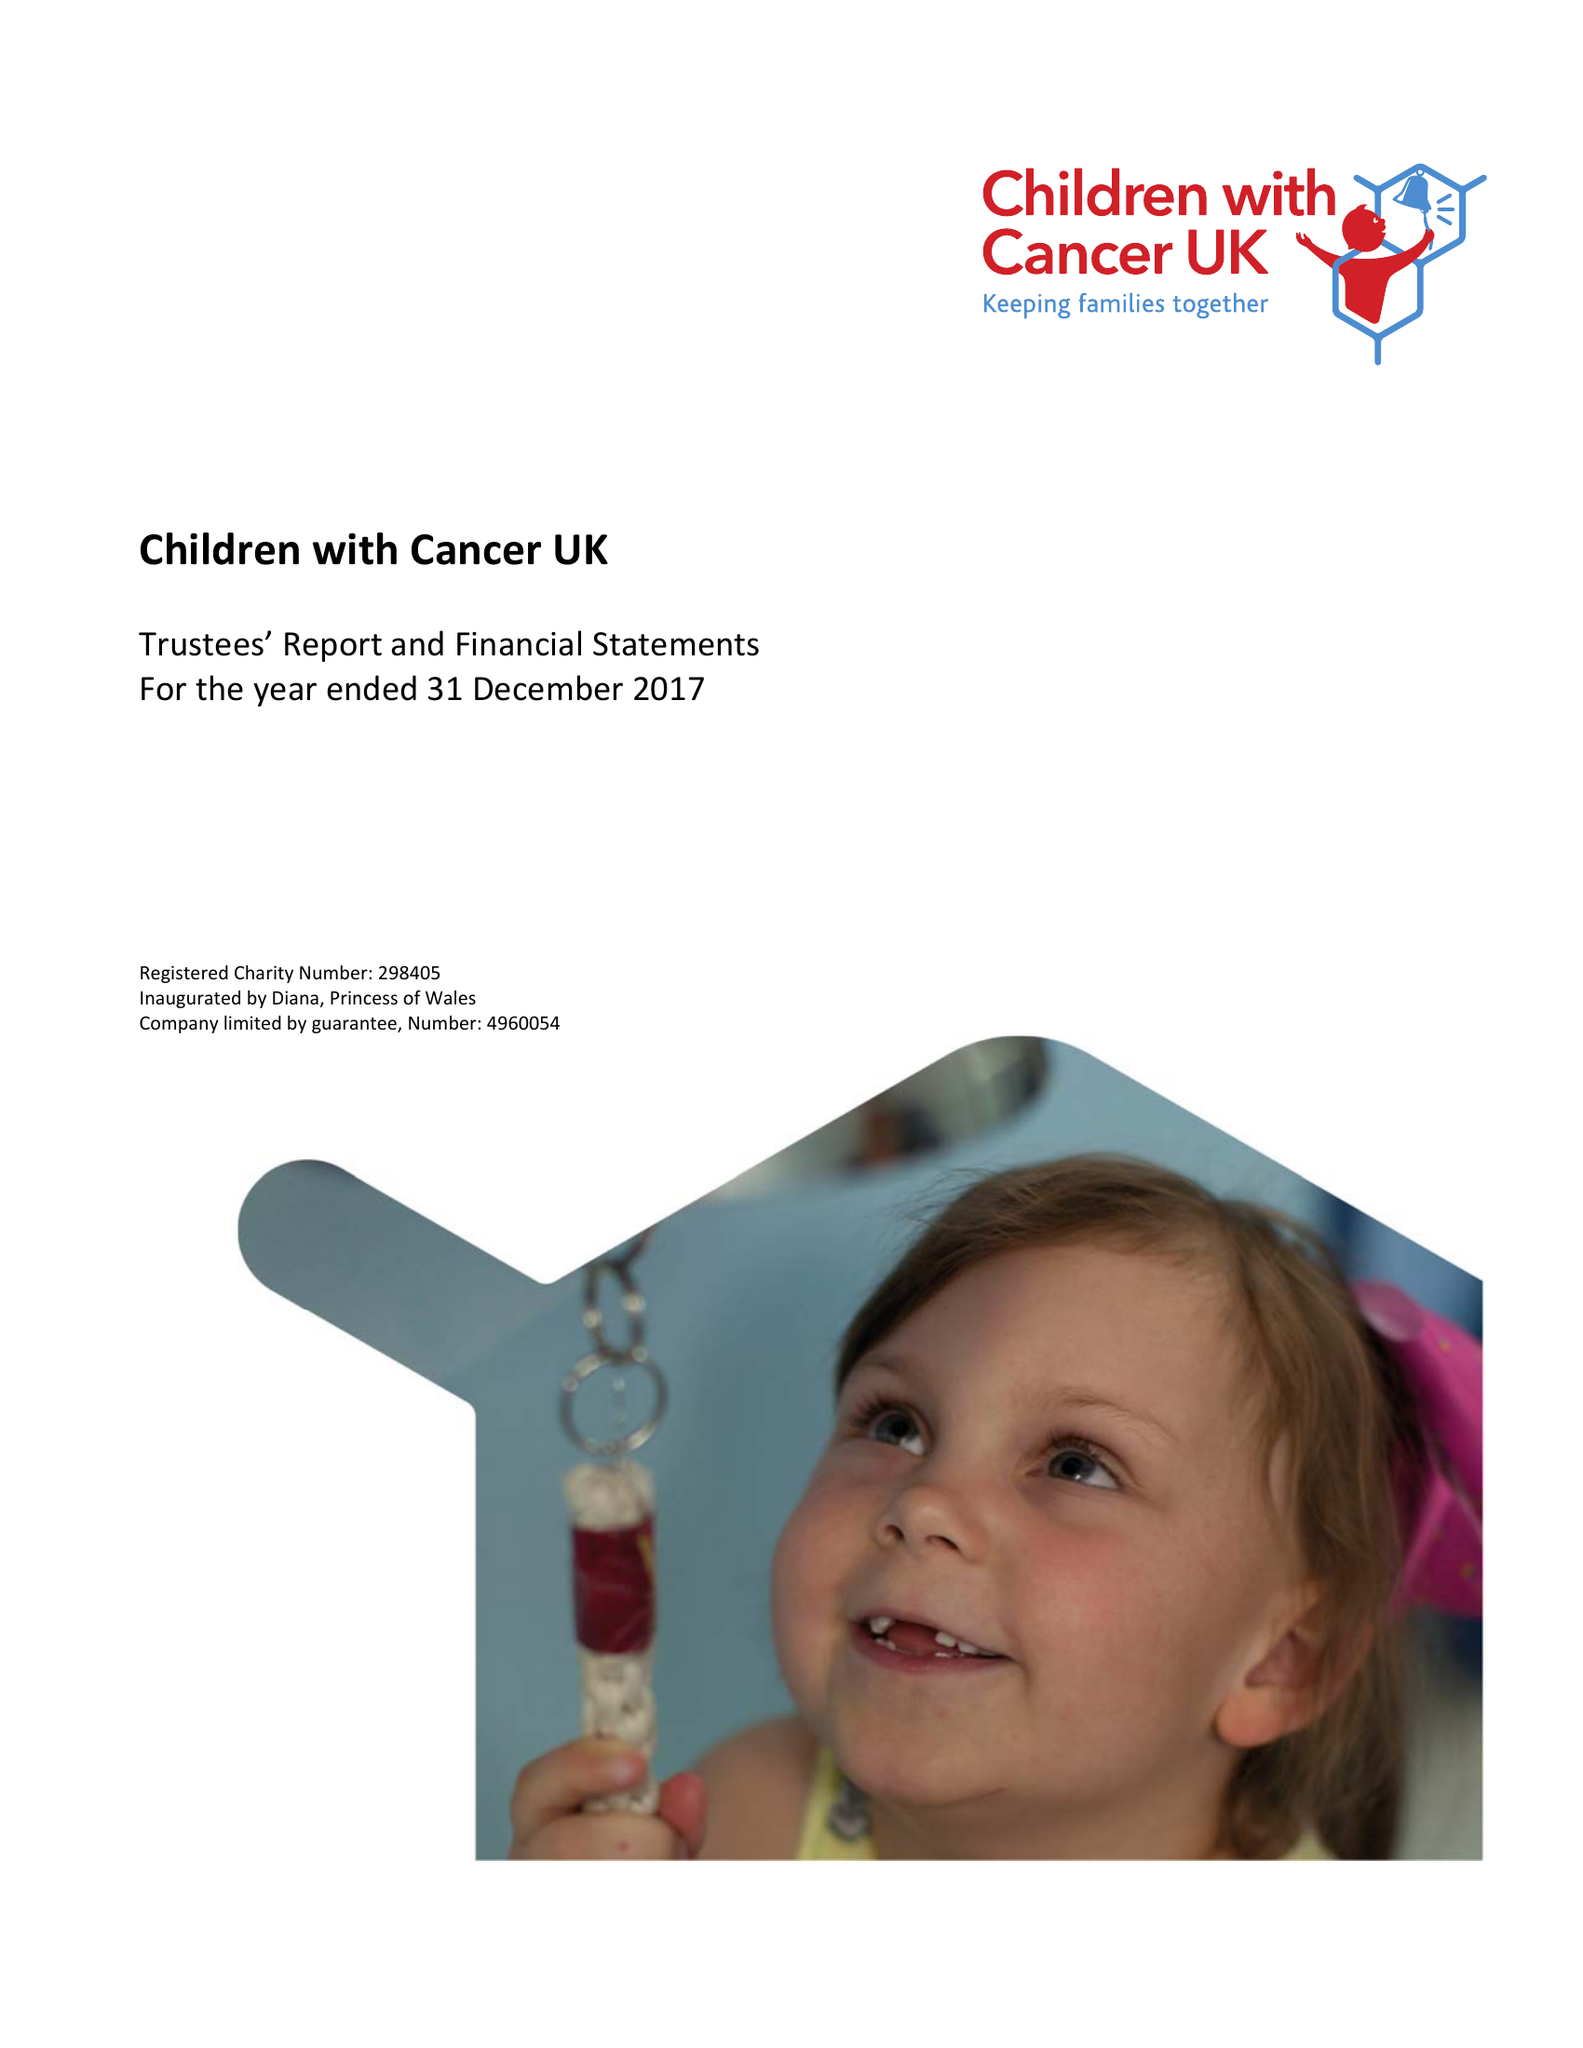What is the value for the report_date?
Answer the question using a single word or phrase. 2017-12-31 